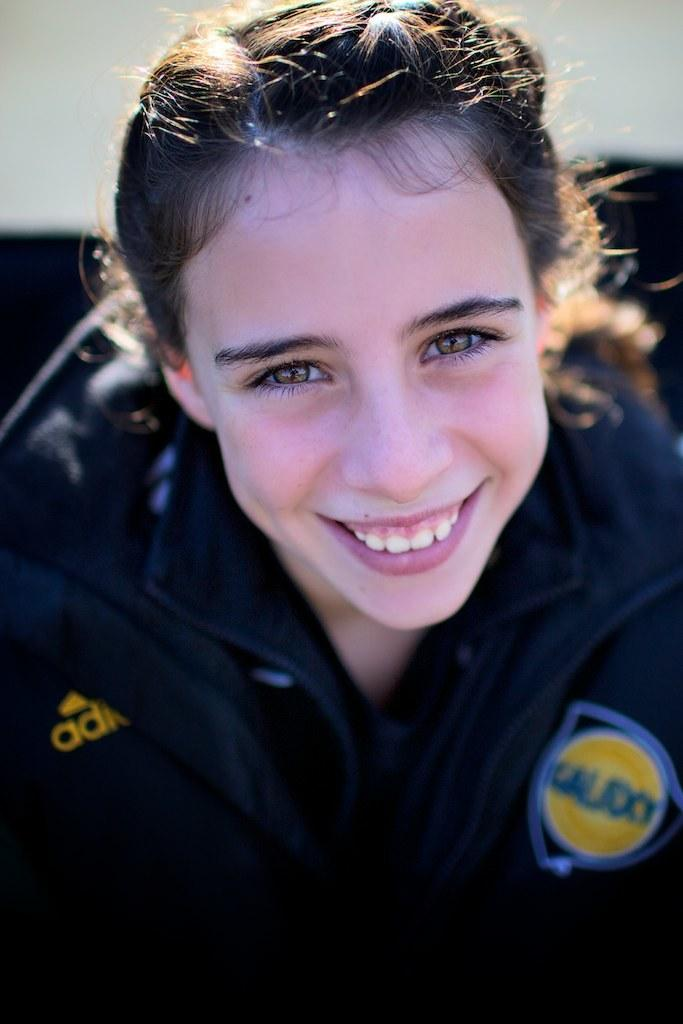Who is present in the image? There is a woman in the image. What is the woman doing in the image? The woman is watching something and smiling. Can you describe the visual quality of the image? There is a blurry view at the bottom of the image. What type of cloth is the woman using to express her idea in the image? There is no cloth or idea present in the image; the woman is simply watching something and smiling. 